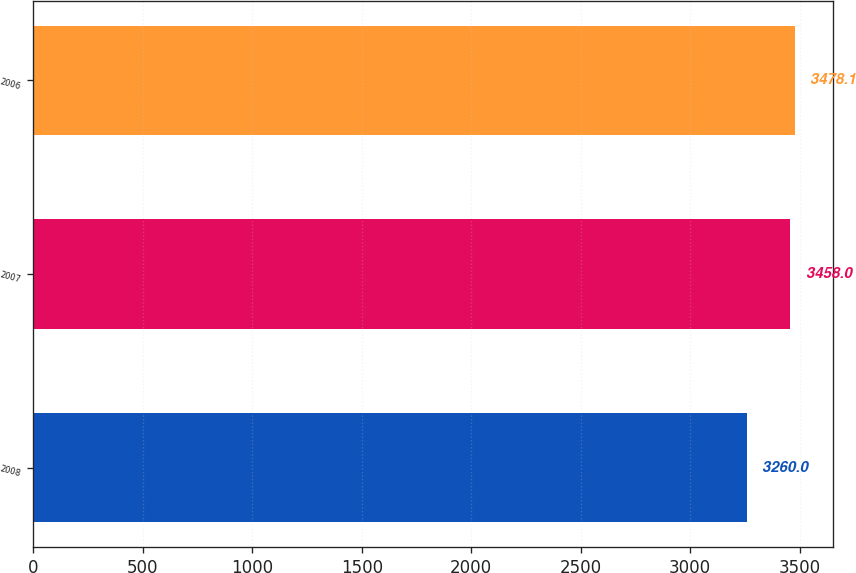Convert chart to OTSL. <chart><loc_0><loc_0><loc_500><loc_500><bar_chart><fcel>2008<fcel>2007<fcel>2006<nl><fcel>3260<fcel>3458<fcel>3478.1<nl></chart> 